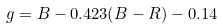<formula> <loc_0><loc_0><loc_500><loc_500>g = B - 0 . 4 2 3 ( B - R ) - 0 . 1 4</formula> 